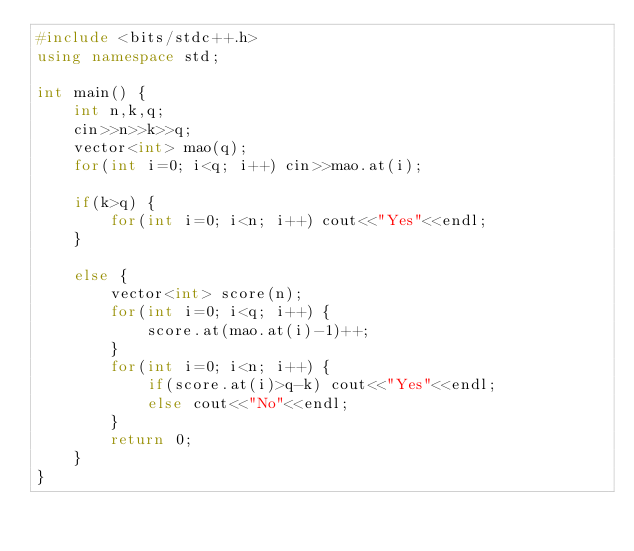Convert code to text. <code><loc_0><loc_0><loc_500><loc_500><_C++_>#include <bits/stdc++.h>
using namespace std;

int main() {
    int n,k,q;
    cin>>n>>k>>q;
    vector<int> mao(q);
    for(int i=0; i<q; i++) cin>>mao.at(i);

    if(k>q) {
        for(int i=0; i<n; i++) cout<<"Yes"<<endl;
    }

    else {
        vector<int> score(n);
        for(int i=0; i<q; i++) {
            score.at(mao.at(i)-1)++;
        }
        for(int i=0; i<n; i++) {
            if(score.at(i)>q-k) cout<<"Yes"<<endl;
            else cout<<"No"<<endl;
        }
        return 0;
    }
}</code> 